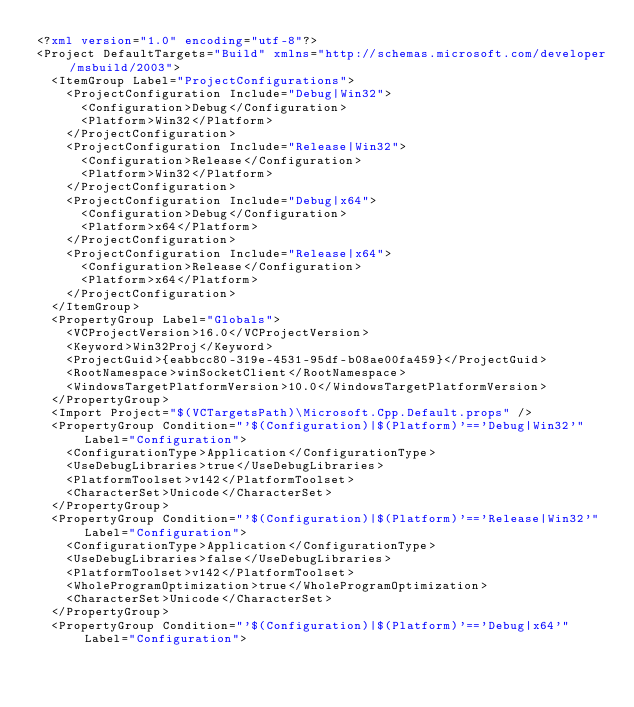<code> <loc_0><loc_0><loc_500><loc_500><_XML_><?xml version="1.0" encoding="utf-8"?>
<Project DefaultTargets="Build" xmlns="http://schemas.microsoft.com/developer/msbuild/2003">
  <ItemGroup Label="ProjectConfigurations">
    <ProjectConfiguration Include="Debug|Win32">
      <Configuration>Debug</Configuration>
      <Platform>Win32</Platform>
    </ProjectConfiguration>
    <ProjectConfiguration Include="Release|Win32">
      <Configuration>Release</Configuration>
      <Platform>Win32</Platform>
    </ProjectConfiguration>
    <ProjectConfiguration Include="Debug|x64">
      <Configuration>Debug</Configuration>
      <Platform>x64</Platform>
    </ProjectConfiguration>
    <ProjectConfiguration Include="Release|x64">
      <Configuration>Release</Configuration>
      <Platform>x64</Platform>
    </ProjectConfiguration>
  </ItemGroup>
  <PropertyGroup Label="Globals">
    <VCProjectVersion>16.0</VCProjectVersion>
    <Keyword>Win32Proj</Keyword>
    <ProjectGuid>{eabbcc80-319e-4531-95df-b08ae00fa459}</ProjectGuid>
    <RootNamespace>winSocketClient</RootNamespace>
    <WindowsTargetPlatformVersion>10.0</WindowsTargetPlatformVersion>
  </PropertyGroup>
  <Import Project="$(VCTargetsPath)\Microsoft.Cpp.Default.props" />
  <PropertyGroup Condition="'$(Configuration)|$(Platform)'=='Debug|Win32'" Label="Configuration">
    <ConfigurationType>Application</ConfigurationType>
    <UseDebugLibraries>true</UseDebugLibraries>
    <PlatformToolset>v142</PlatformToolset>
    <CharacterSet>Unicode</CharacterSet>
  </PropertyGroup>
  <PropertyGroup Condition="'$(Configuration)|$(Platform)'=='Release|Win32'" Label="Configuration">
    <ConfigurationType>Application</ConfigurationType>
    <UseDebugLibraries>false</UseDebugLibraries>
    <PlatformToolset>v142</PlatformToolset>
    <WholeProgramOptimization>true</WholeProgramOptimization>
    <CharacterSet>Unicode</CharacterSet>
  </PropertyGroup>
  <PropertyGroup Condition="'$(Configuration)|$(Platform)'=='Debug|x64'" Label="Configuration"></code> 